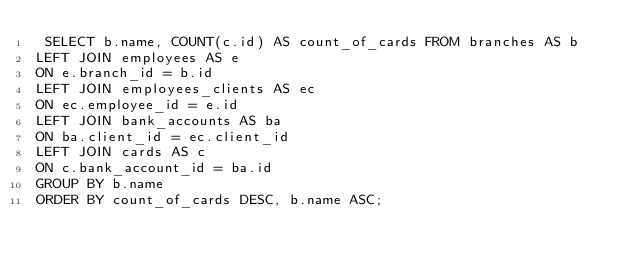Convert code to text. <code><loc_0><loc_0><loc_500><loc_500><_SQL_> SELECT b.name, COUNT(c.id) AS count_of_cards FROM branches AS b
LEFT JOIN employees AS e
ON e.branch_id = b.id
LEFT JOIN employees_clients AS ec
ON ec.employee_id = e.id
LEFT JOIN bank_accounts AS ba
ON ba.client_id = ec.client_id
LEFT JOIN cards AS c
ON c.bank_account_id = ba.id
GROUP BY b.name
ORDER BY count_of_cards DESC, b.name ASC;</code> 